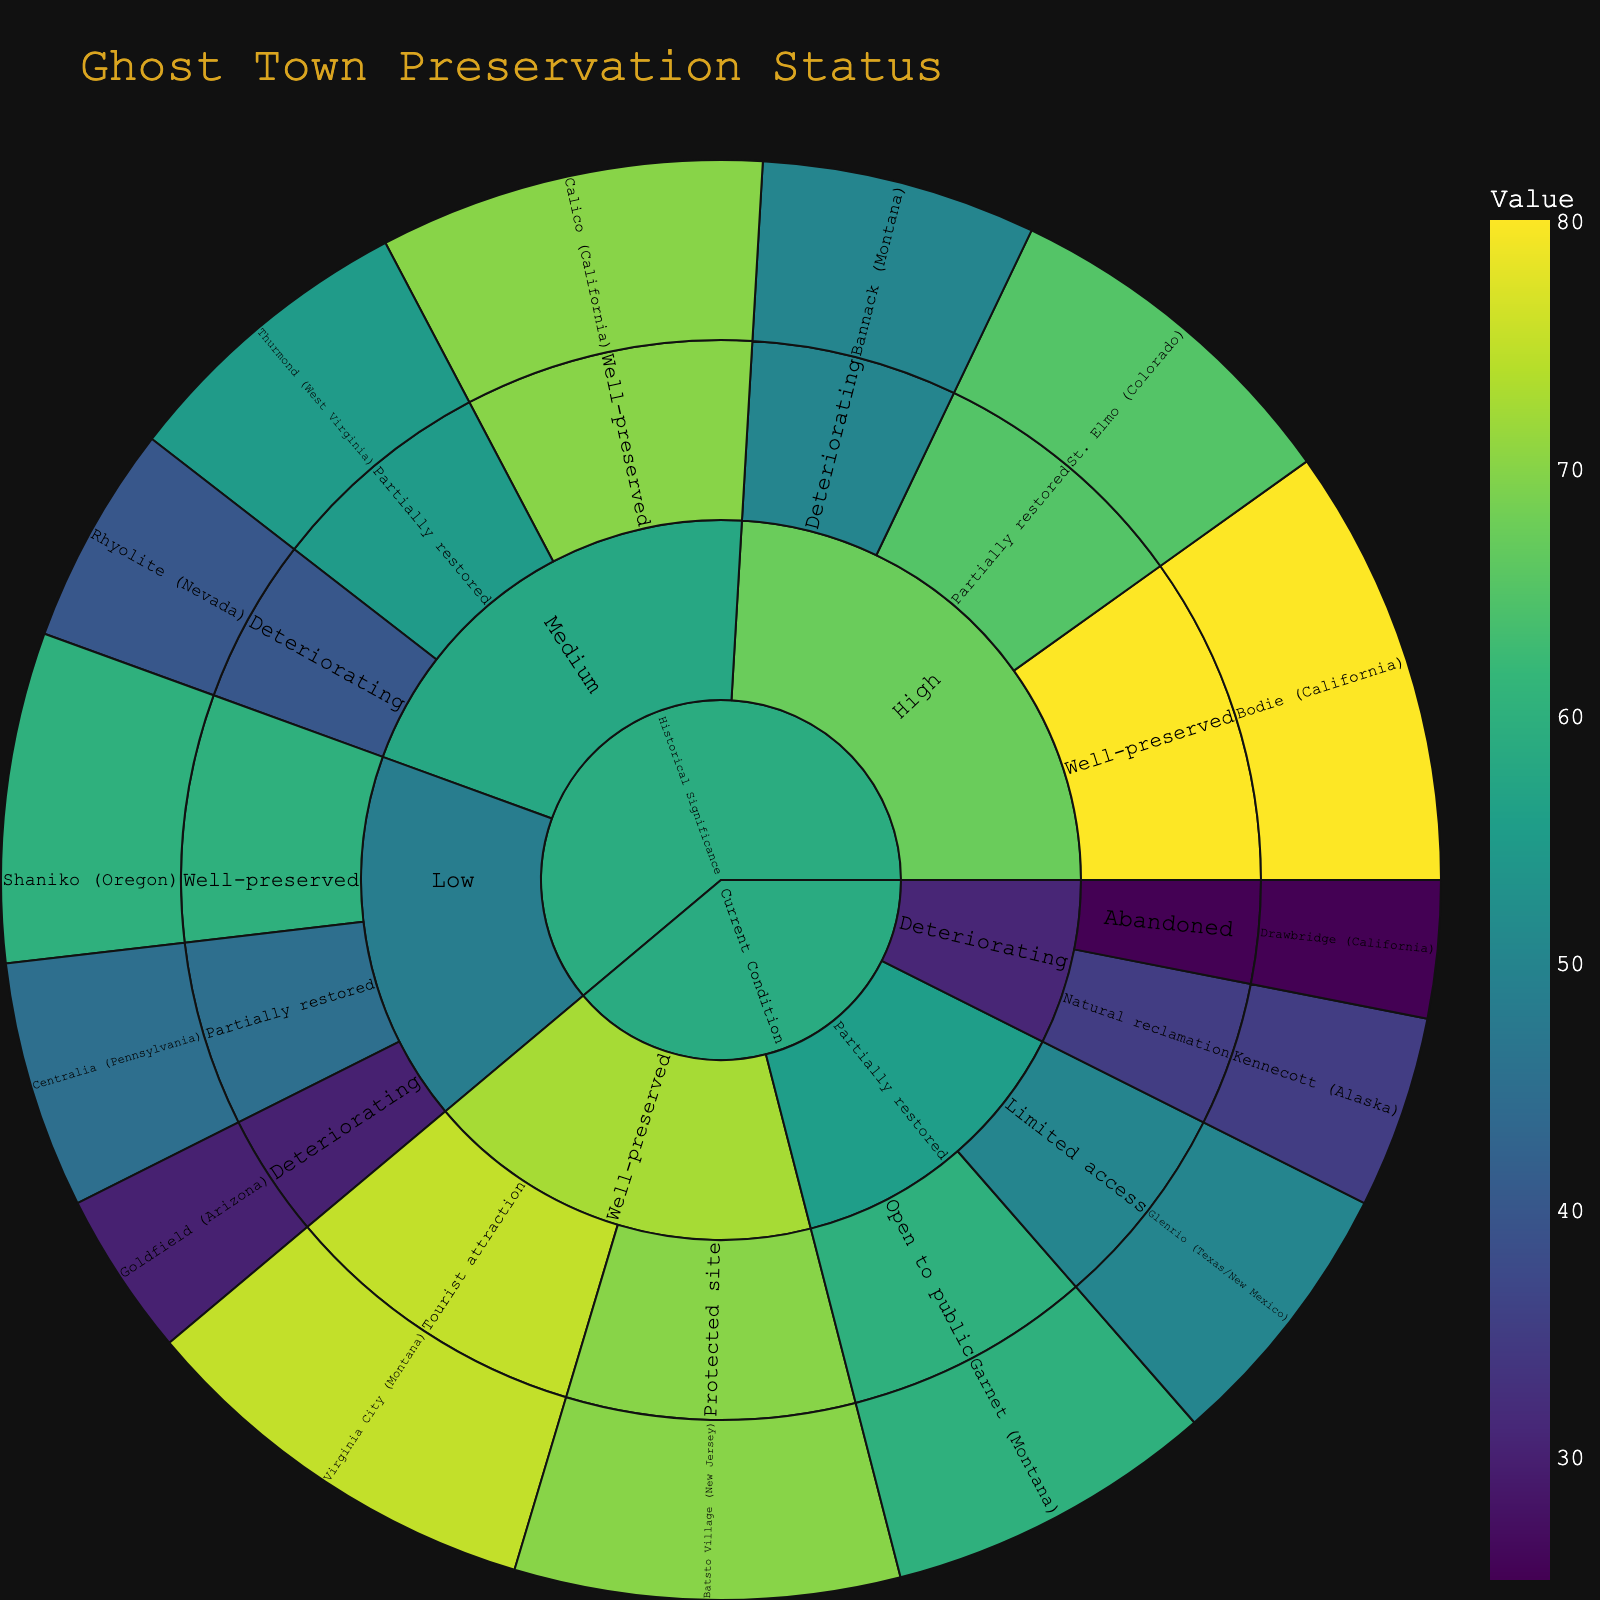What category is divided into High, Medium, and Low subcategories? In the Sunburst plot, the "Historical Significance" category is subdivided into High, Medium, and Low based on historical significance levels.
Answer: Historical Significance Which ghost town has the highest value in the High historical significance subcategory? In the High historical significance subcategory, Bodie (California) is the ghost town with the highest value, which is directly indicated by the largest segment in that subcategory.
Answer: Bodie (California) How many ghost towns are Well-preserved under the Current Condition category? Under the Current Condition category, the Well-preserved subcategory includes two ghost towns: Virginia City (Montana) and Batsto Village (New Jersey). Hence, there are two ghost towns.
Answer: Two Which subcategory has the lowest value in the Medium Historical Significance category? In the Medium Historical Significance category, the Deteriorating subcategory, represented by Rhyolite (Nevada), has the lowest value. This is indicated by the smallest segment size within that subcategory.
Answer: Deteriorating What is the cumulative value of all Well-preserved ghost towns? Sum the values of all Well-preserved ghost towns: Bodie (California) – 80, Calico (California) – 70, Shaniko (Oregon) – 60, Virginia City (Montana) – 75, Batsto Village (New Jersey) – 70. The total is 80 + 70 + 60 + 75 + 70 = 355.
Answer: 355 Compare the values of Centralia (Pennsylvania) and Glenrio (Texas/New Mexico). Which has a higher value? Centralia (Pennsylvania) has a value of 45, and Glenrio (Texas/New Mexico) has a value of 50. Therefore, Glenrio has a higher value than Centralia.
Answer: Glenrio (Texas/New Mexico) Which ghost town falls under the category High Historical Significance but is Deteriorating? Within High Historical Significance and Deteriorating categories, Bannack (Montana) is the ghost town that fits this description.
Answer: Bannack (Montana) Is the value of Kennecott (Alaska) greater than Drawbridge (California) under Deteriorating Current Condition? Kennecott (Alaska) has a value of 35 and Drawbridge (California) has a value of 25. Thus, Kennecott's value is greater.
Answer: Yes What town has the highest value in the Partially restored subcategory across both categories? In the Partially restored subcategory, St. Elmo (Colorado) with a value of 65 has the highest value across both categories.
Answer: St. Elmo (Colorado) Which category section has more towns, Historical Significance or Current Condition? The Historical Significance category includes nine ghost towns, while the Current Condition category includes six ghost towns. Therefore, Historical Significance has more ghost towns.
Answer: Historical Significance 